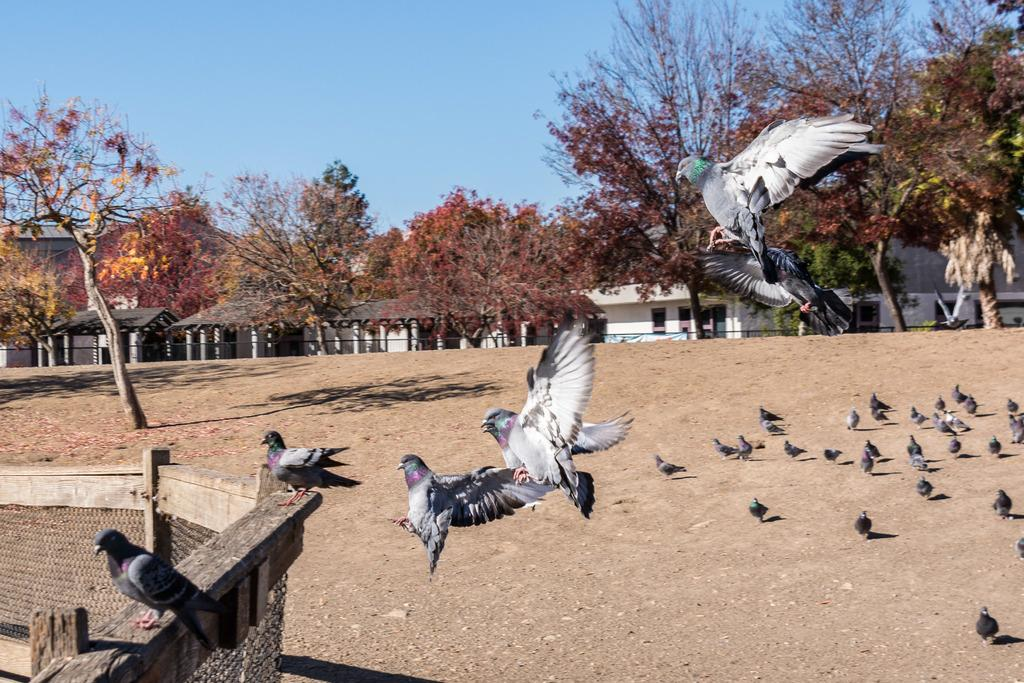What type of structures are visible in the image? There are houses in the image. What features do the houses have? The houses have windows. What other elements can be seen in the image besides the houses? There are trees, birds on the ground, birds flying, and two birds on a wooden object in the image. What is the color of the sky in the image? The sky is blue in color. Can you tell me how many men are standing near the houses in the image? There is no man present in the image; it only features houses, trees, and birds. What type of heat source can be seen in the image? There is no heat source visible in the image. 